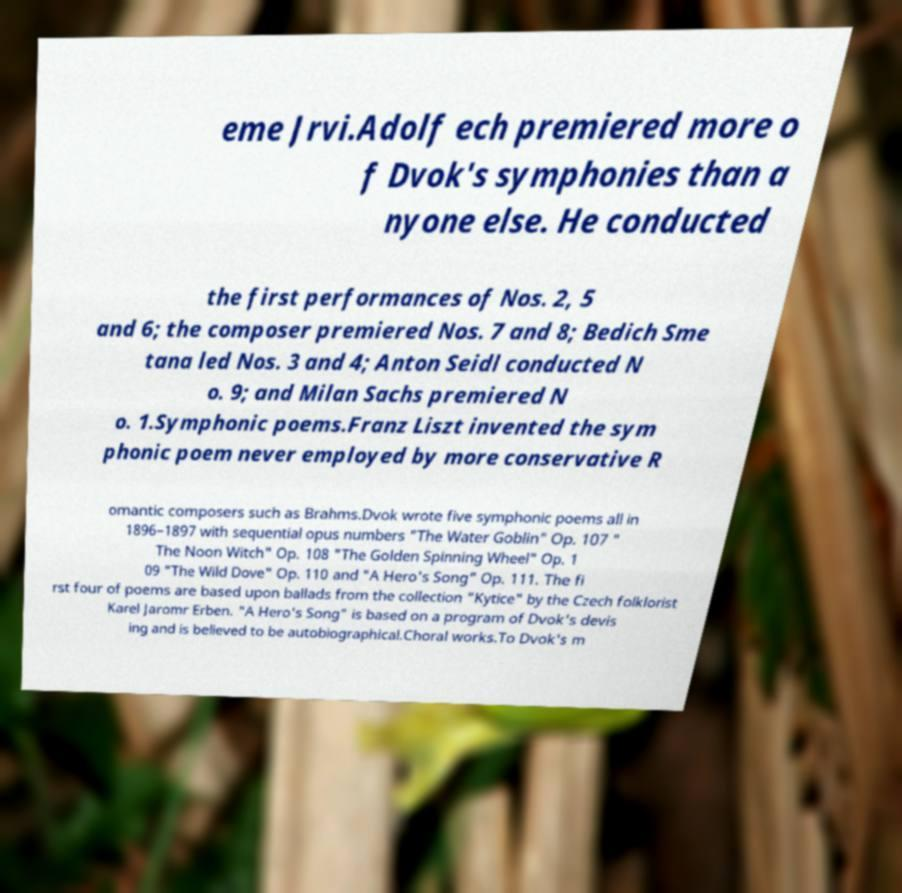Could you assist in decoding the text presented in this image and type it out clearly? eme Jrvi.Adolf ech premiered more o f Dvok's symphonies than a nyone else. He conducted the first performances of Nos. 2, 5 and 6; the composer premiered Nos. 7 and 8; Bedich Sme tana led Nos. 3 and 4; Anton Seidl conducted N o. 9; and Milan Sachs premiered N o. 1.Symphonic poems.Franz Liszt invented the sym phonic poem never employed by more conservative R omantic composers such as Brahms.Dvok wrote five symphonic poems all in 1896–1897 with sequential opus numbers "The Water Goblin" Op. 107 " The Noon Witch" Op. 108 "The Golden Spinning Wheel" Op. 1 09 "The Wild Dove" Op. 110 and "A Hero's Song" Op. 111. The fi rst four of poems are based upon ballads from the collection "Kytice" by the Czech folklorist Karel Jaromr Erben. "A Hero's Song" is based on a program of Dvok's devis ing and is believed to be autobiographical.Choral works.To Dvok's m 